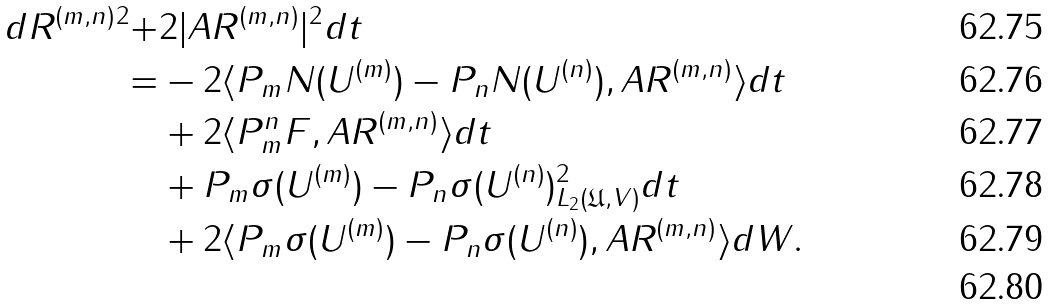Convert formula to latex. <formula><loc_0><loc_0><loc_500><loc_500>d \| R ^ { ( m , n ) } \| ^ { 2 } + & 2 | A R ^ { ( m , n ) } | ^ { 2 } d t \\ = & - 2 \langle P _ { m } N ( U ^ { ( m ) } ) - P _ { n } N ( U ^ { ( n ) } ) , A R ^ { ( m , n ) } \rangle d t \\ & + 2 \langle P _ { m } ^ { n } F , A R ^ { ( m , n ) } \rangle d t \\ & + \| P _ { m } \sigma ( U ^ { ( m ) } ) - P _ { n } \sigma ( U ^ { ( n ) } ) \| ^ { 2 } _ { L _ { 2 } ( \mathfrak { U } , V ) } d t \\ & + 2 \langle P _ { m } \sigma ( U ^ { ( m ) } ) - P _ { n } \sigma ( U ^ { ( n ) } ) , A R ^ { ( m , n ) } \rangle d W . \\</formula> 